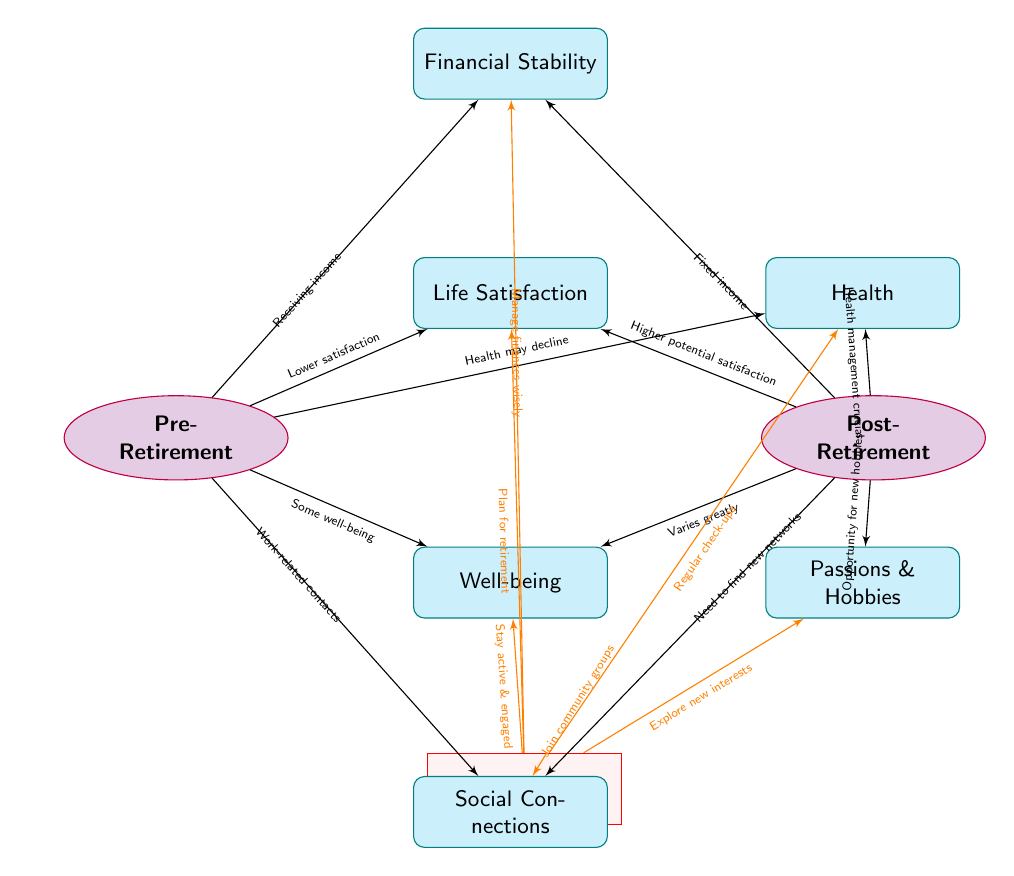What is the relationship between pre-retirement and life satisfaction? The edge connects these two nodes and indicates that pre-retirement is associated with "Lower satisfaction" in life.
Answer: Lower satisfaction What does the arrow indicate about financial stability pre-retirement? The arrow points from pre-retirement to financial stability with the label "Receiving income," showing that individuals typically experience financial stability before retirement due to their income from work.
Answer: Receiving income What two factors are indicated to vary greatly in well-being post-retirement? The edge directed towards well-being from post-retirement shows that well-being can "Varies greatly," implying a higher potential for a diverse range of well-being experiences after retirement.
Answer: Varies greatly What advice is given regarding health management? The path from advice to health states "Regular check-ups," indicating a recommendation for managing health post-retirement.
Answer: Regular check-ups How many nodes are connected to the post-retirement phase? By counting the nodes linked to the post-retirement phase; life satisfaction, well-being, health, passions & hobbies, and social connections total up to five nodes.
Answer: Five nodes What is indicated about social connections post-retirement? The edge from post-retirement to social connections states that there is a "Need to find new networks," which suggests a challenge faced after retiring.
Answer: Need to find new networks Which node exceeds pre-retirement satisfaction and why? Life satisfaction in post-retirement is indicated to have "Higher potential satisfaction," suggesting a possibility for increased satisfaction post-retirement if actively managed.
Answer: Higher potential satisfaction What advice is associated with exploring new interests? The arrow from advice to passions & hobbies suggests that people are encouraged to "Explore new interests," highlighting this as a key recommendation for post-retirement fulfillment.
Answer: Explore new interests What is the main theme conveyed in the advice node? The advice node encompasses the notion of "Plan for retirement," focusing on proactive preparation as the overarching theme within the context of life satisfaction and well-being.
Answer: Plan for retirement 